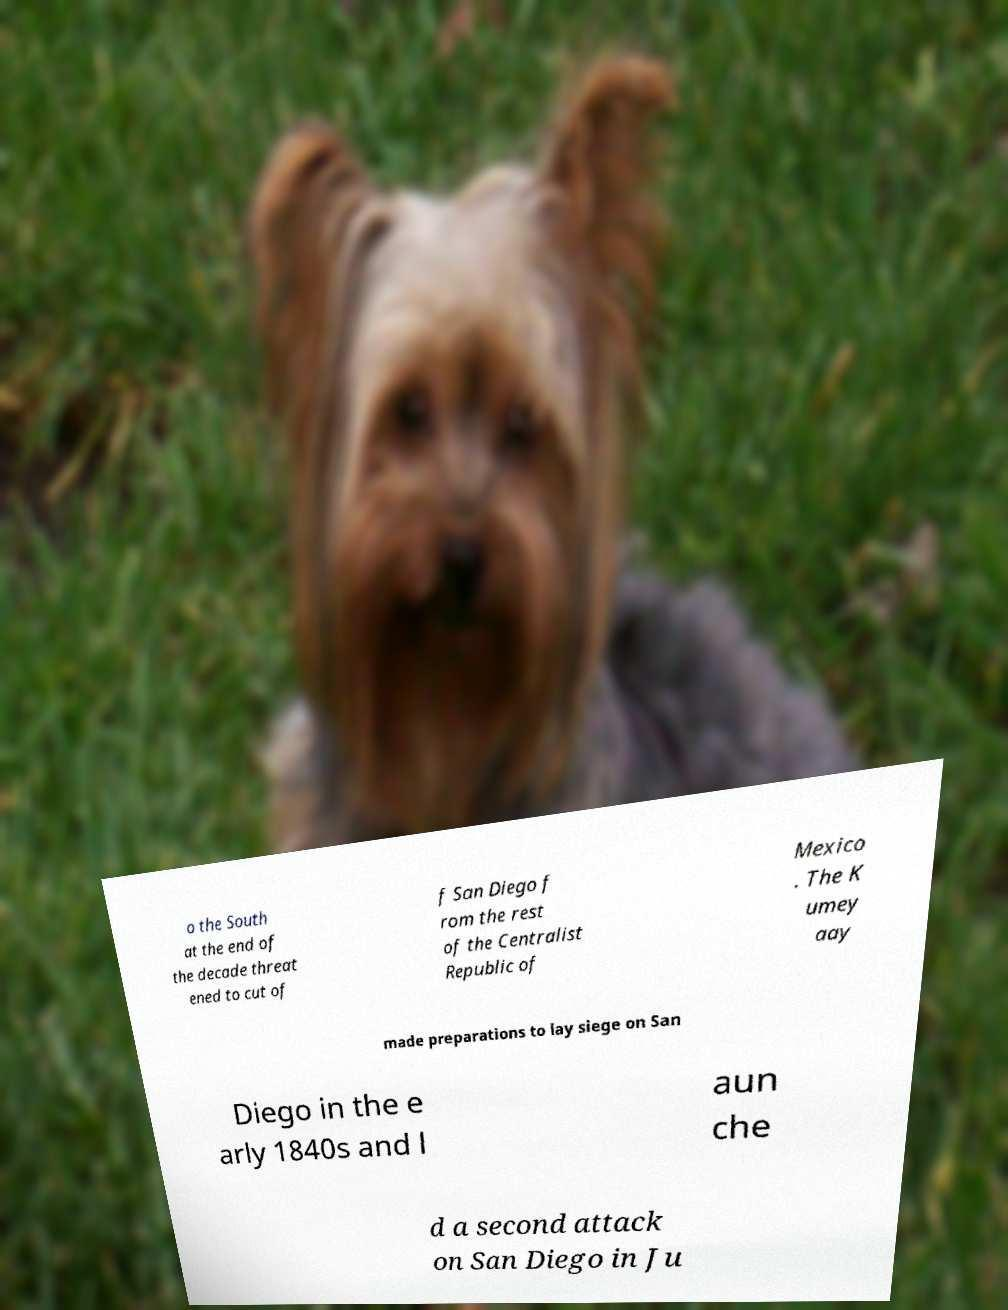Could you assist in decoding the text presented in this image and type it out clearly? o the South at the end of the decade threat ened to cut of f San Diego f rom the rest of the Centralist Republic of Mexico . The K umey aay made preparations to lay siege on San Diego in the e arly 1840s and l aun che d a second attack on San Diego in Ju 